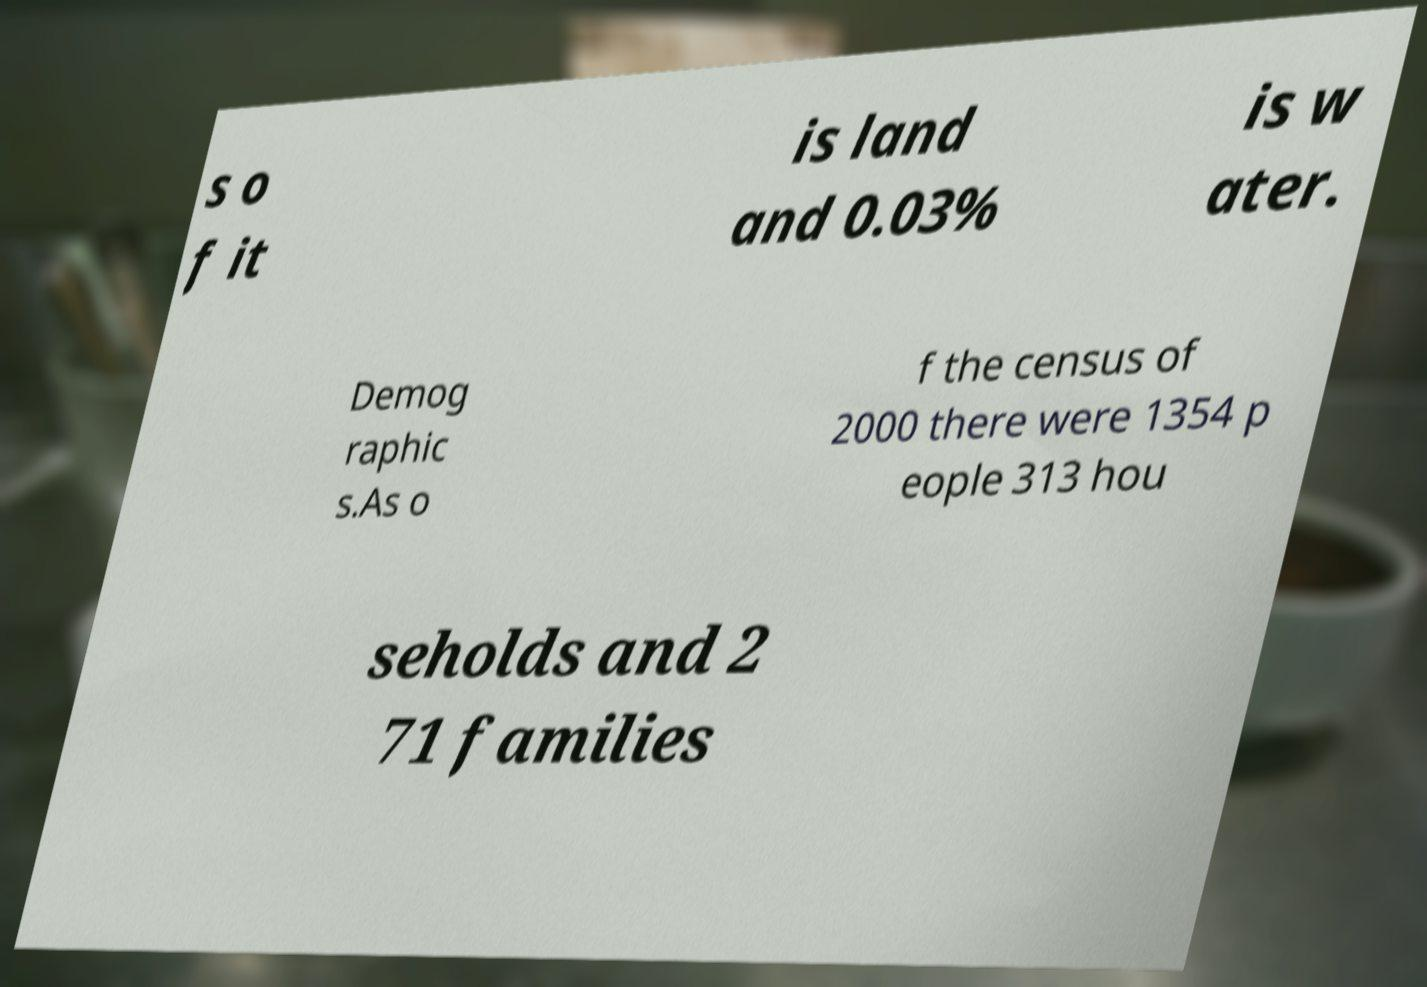Please identify and transcribe the text found in this image. s o f it is land and 0.03% is w ater. Demog raphic s.As o f the census of 2000 there were 1354 p eople 313 hou seholds and 2 71 families 